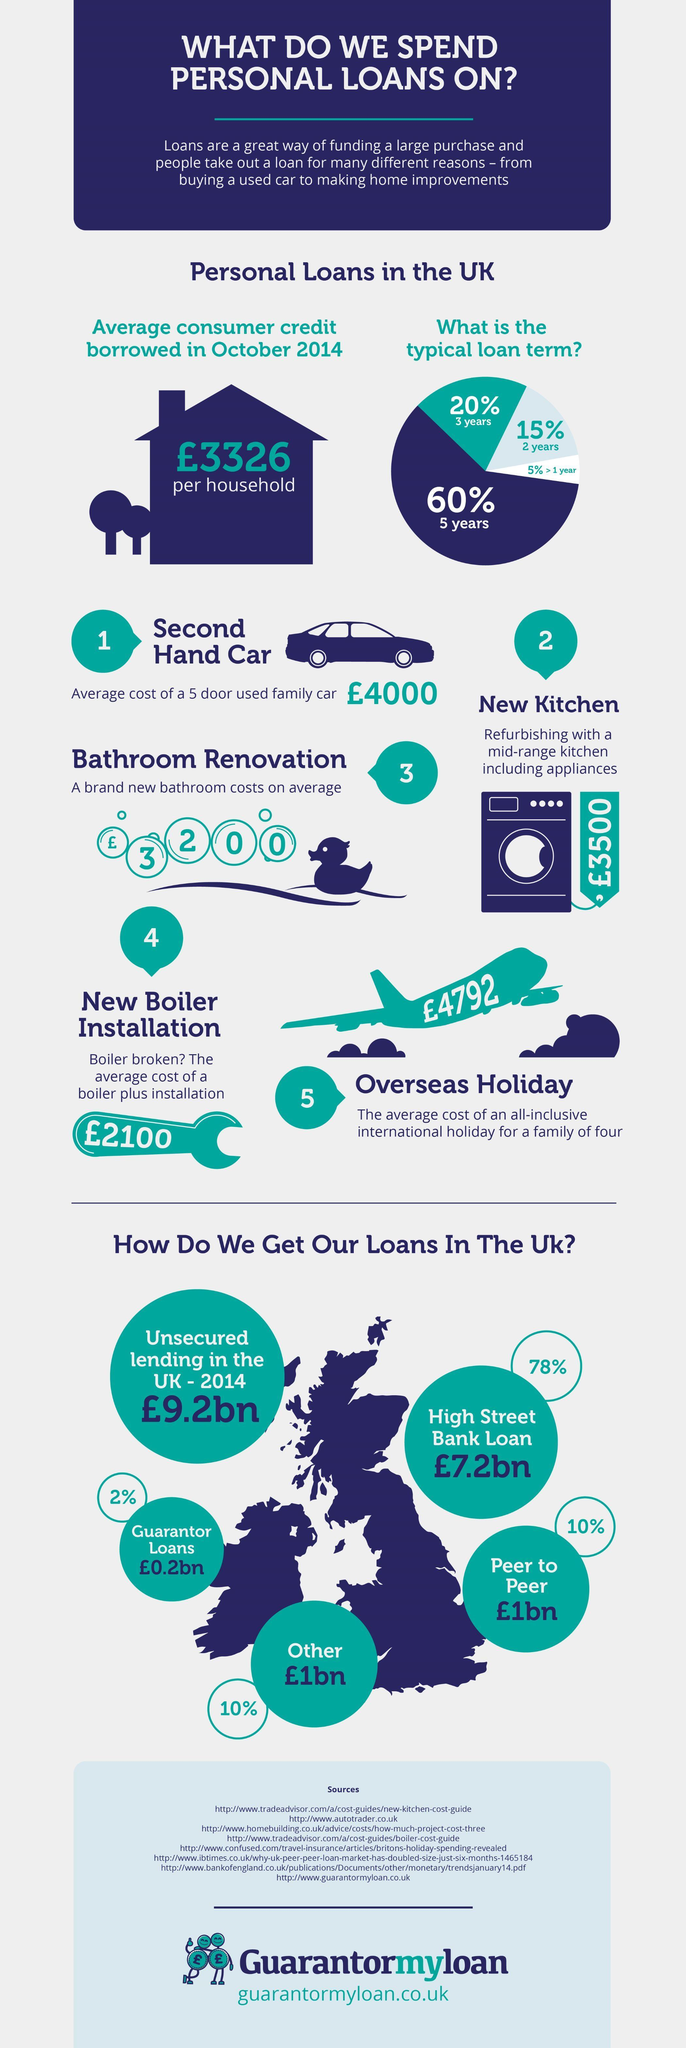According to the image, what can you get for £4000?
Answer the question with a short phrase. Second hand car What is the cost of refurbishing a kitchen (in pounds)? 3500 How much does a brand new bathroom cost (in pounds)? 3200 How much would it cost (in pounds) to install a new boiler? 2100 What is the shortest term available for a personal loan? 1 year What percentage of people take loans from their peer? 10% Which is the major source of loans in UK? High Street Bank How many typical loan terms are available? 4 What is the average cost (in pounds) of an all inclusive international holiday for a family of 4? 4792 What percentage of loans taken, have a five year term? 60% 